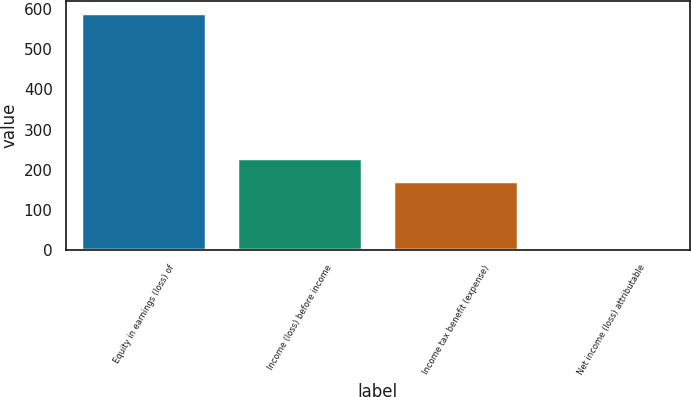<chart> <loc_0><loc_0><loc_500><loc_500><bar_chart><fcel>Equity in earnings (loss) of<fcel>Income (loss) before income<fcel>Income tax benefit (expense)<fcel>Net income (loss) attributable<nl><fcel>590<fcel>230.1<fcel>172<fcel>9<nl></chart> 